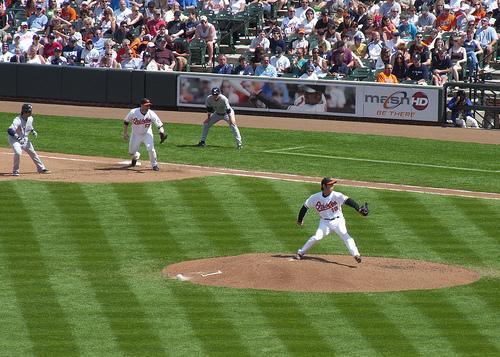How many pitchers are there?
Give a very brief answer. 1. 